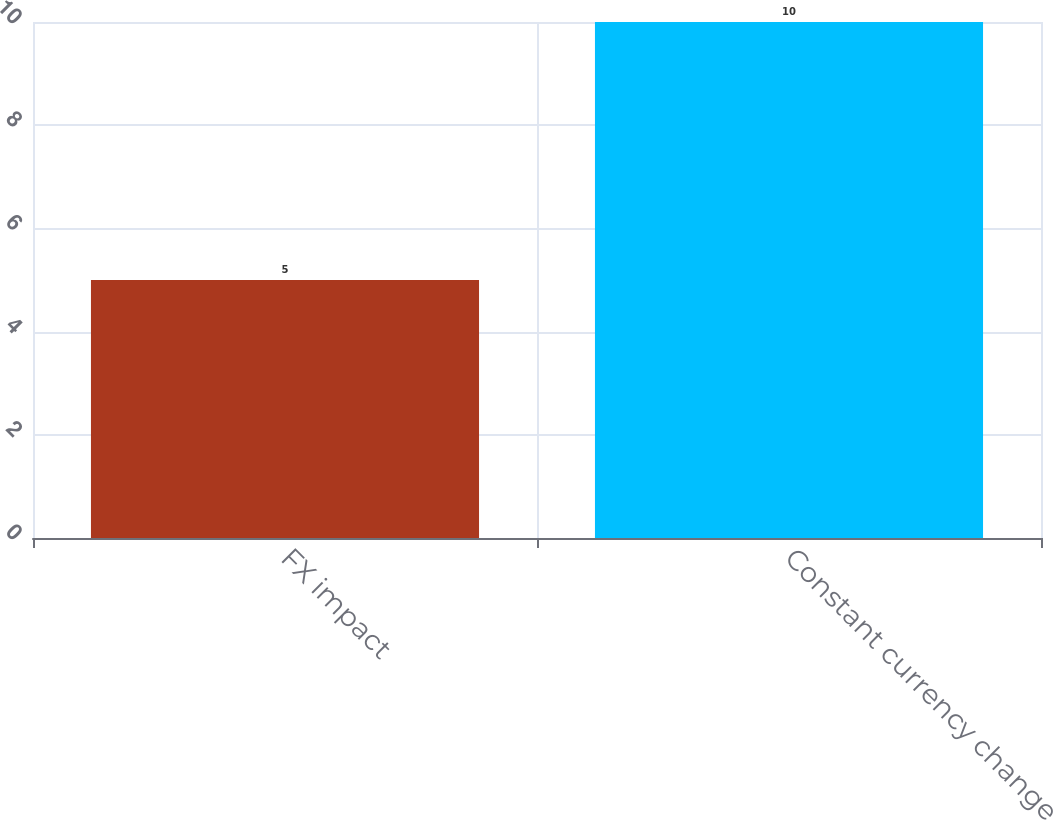Convert chart. <chart><loc_0><loc_0><loc_500><loc_500><bar_chart><fcel>FX impact<fcel>Constant currency change<nl><fcel>5<fcel>10<nl></chart> 